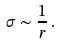<formula> <loc_0><loc_0><loc_500><loc_500>\sigma \sim \frac { 1 } { r } \, .</formula> 